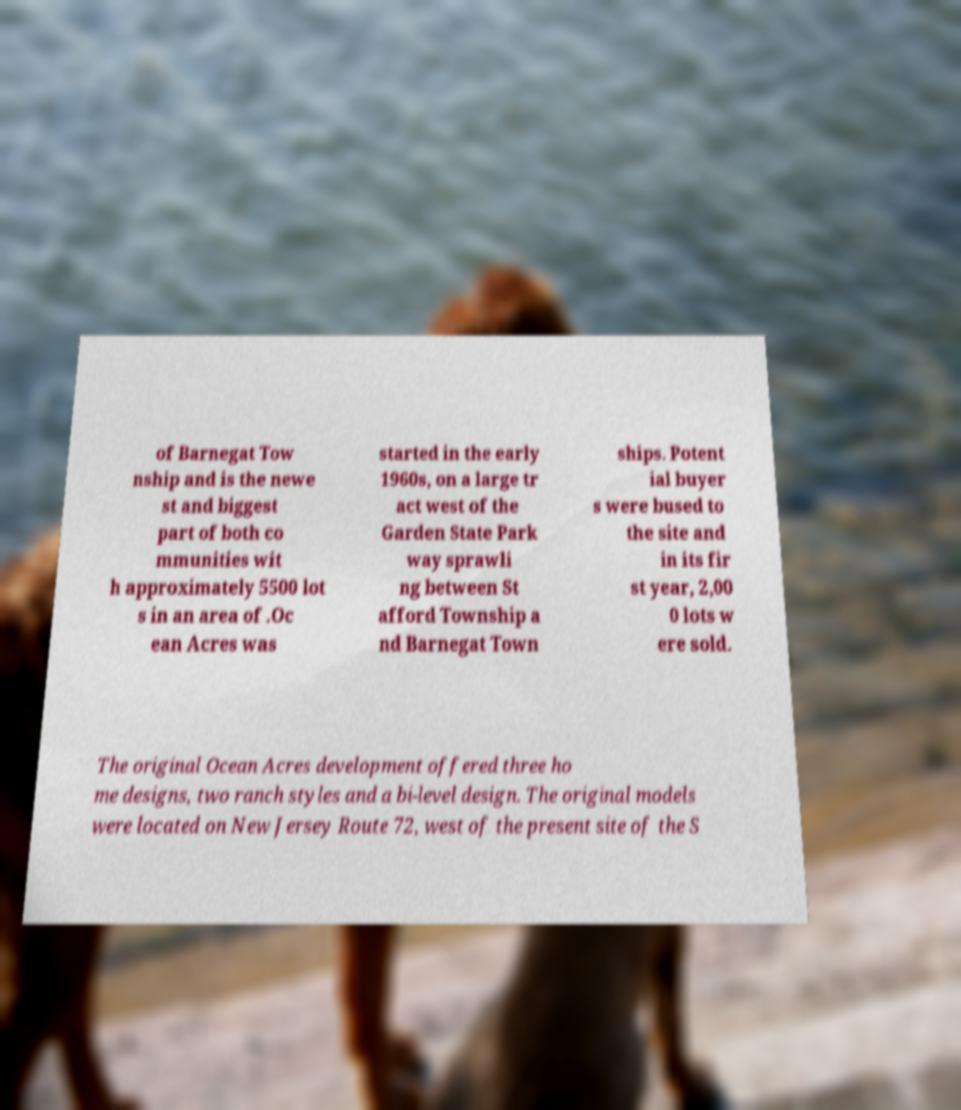Could you assist in decoding the text presented in this image and type it out clearly? of Barnegat Tow nship and is the newe st and biggest part of both co mmunities wit h approximately 5500 lot s in an area of .Oc ean Acres was started in the early 1960s, on a large tr act west of the Garden State Park way sprawli ng between St afford Township a nd Barnegat Town ships. Potent ial buyer s were bused to the site and in its fir st year, 2,00 0 lots w ere sold. The original Ocean Acres development offered three ho me designs, two ranch styles and a bi-level design. The original models were located on New Jersey Route 72, west of the present site of the S 